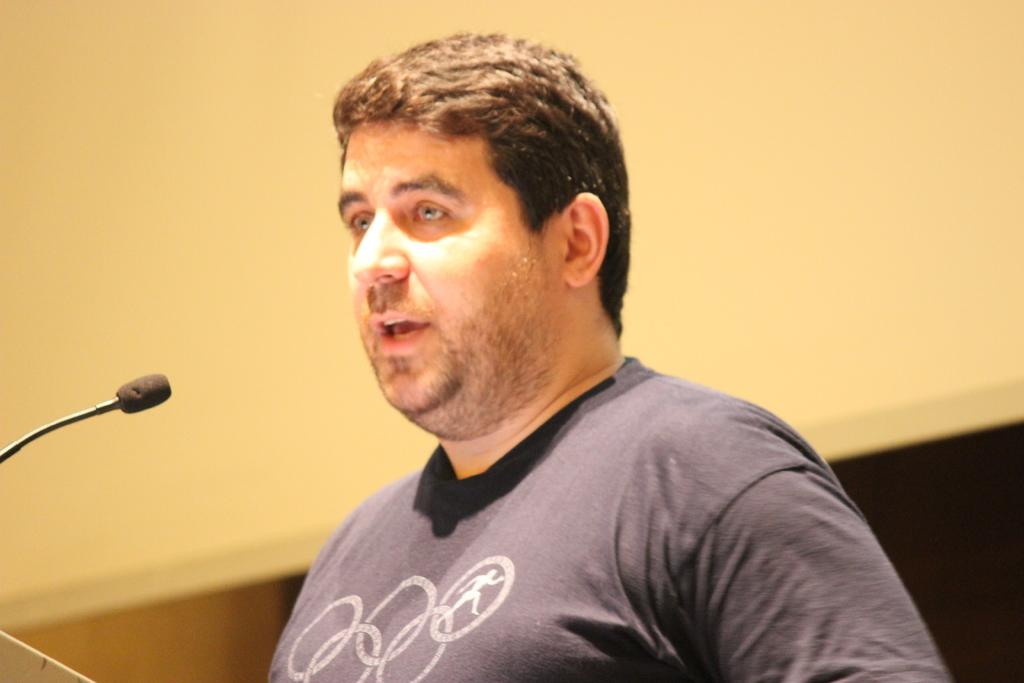Who is present in the image? There is a man in the image. What is the man wearing? The man is wearing clothes. What object can be seen in the image that is typically used for amplifying sound? There is a microphone in the image. Can you describe the background of the image? The background of the image is blurred. What type of cabbage is being used as a hat in the image? There is no cabbage present in the image, let alone being used as a hat. 